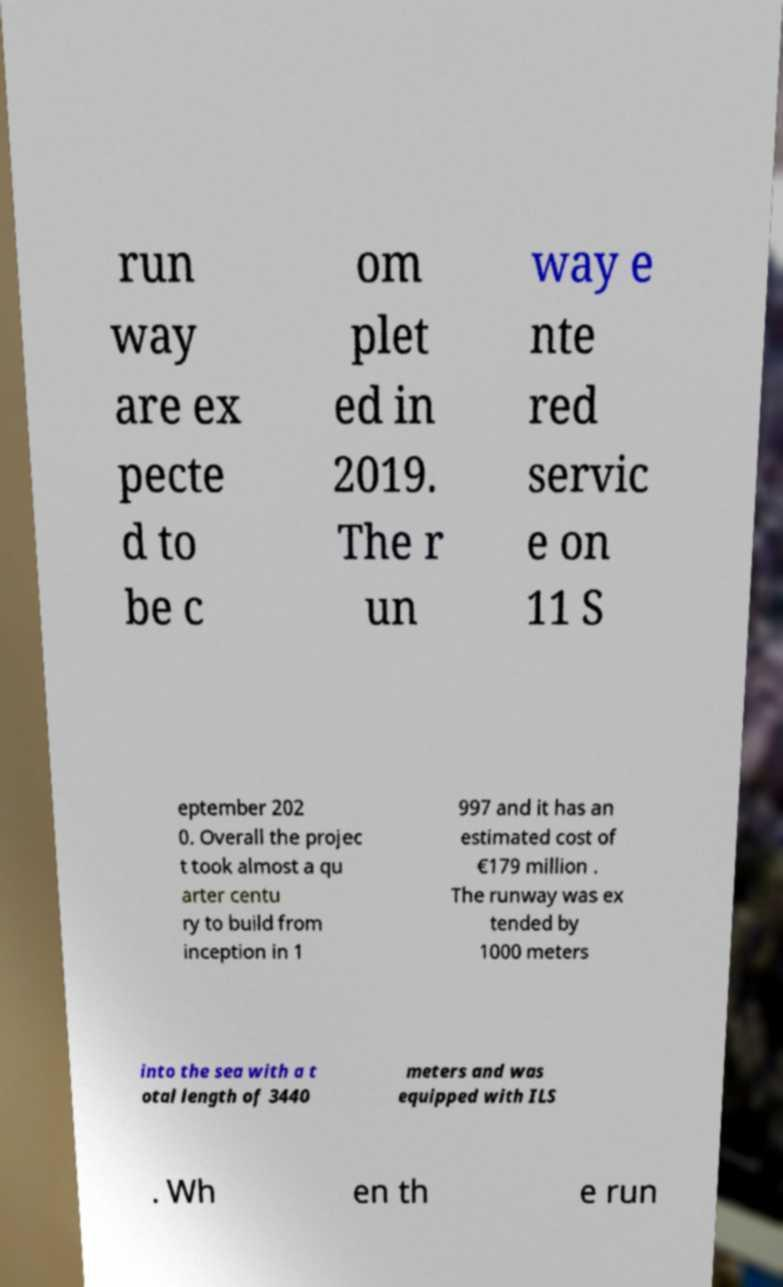Could you extract and type out the text from this image? run way are ex pecte d to be c om plet ed in 2019. The r un way e nte red servic e on 11 S eptember 202 0. Overall the projec t took almost a qu arter centu ry to build from inception in 1 997 and it has an estimated cost of €179 million . The runway was ex tended by 1000 meters into the sea with a t otal length of 3440 meters and was equipped with ILS . Wh en th e run 